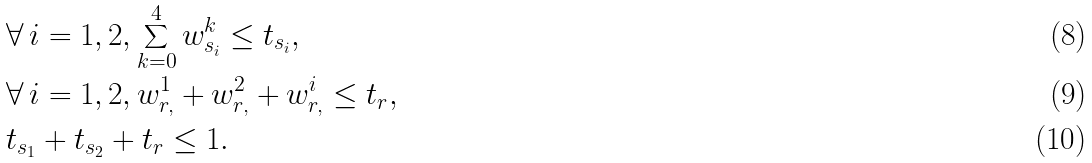<formula> <loc_0><loc_0><loc_500><loc_500>& \forall \, i = 1 , 2 , \sum _ { k = 0 } ^ { 4 } w ^ { k } _ { s _ { i } } \leq t _ { s _ { i } } , \\ & \forall \, i = 1 , 2 , w ^ { 1 } _ { r , } + w ^ { 2 } _ { r , } + w ^ { i } _ { r , } \leq t _ { r } , \\ & t _ { s _ { 1 } } + t _ { s _ { 2 } } + t _ { r } \leq 1 .</formula> 